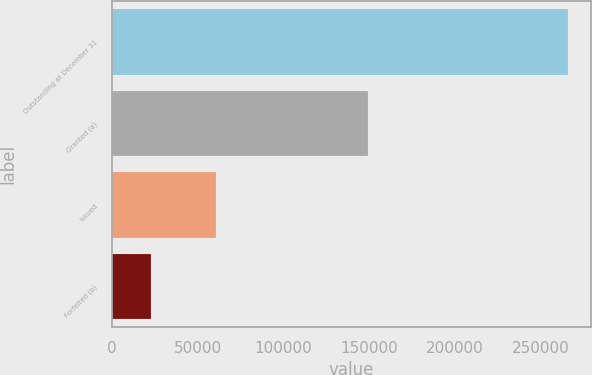Convert chart to OTSL. <chart><loc_0><loc_0><loc_500><loc_500><bar_chart><fcel>Outstanding at December 31<fcel>Granted (a)<fcel>Issued<fcel>Forfeited (b)<nl><fcel>266238<fcel>149500<fcel>60912<fcel>22500<nl></chart> 